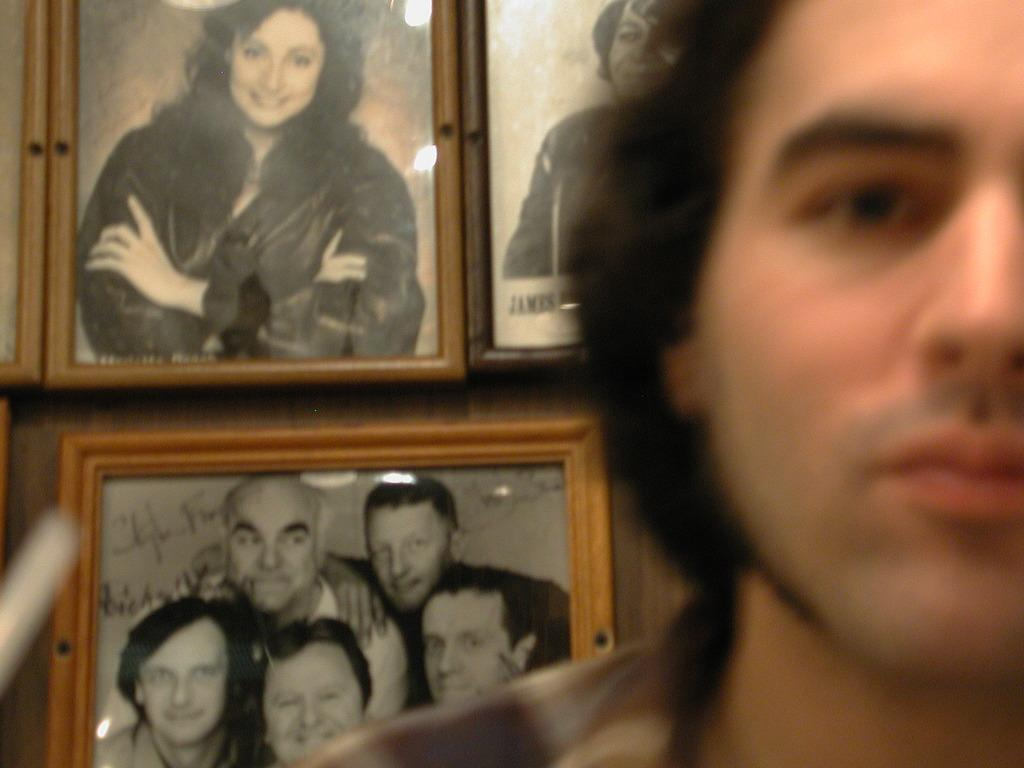Who is the main subject in the front of the image? There is a man in the front of the image. What can be seen in the background of the image? There are three photo frames in the background of the image. What do the photo frames contain? The photo frames contain pictures of persons. Can you hear a whistle in the image? There is no mention of a whistle in the image, so it cannot be heard. 